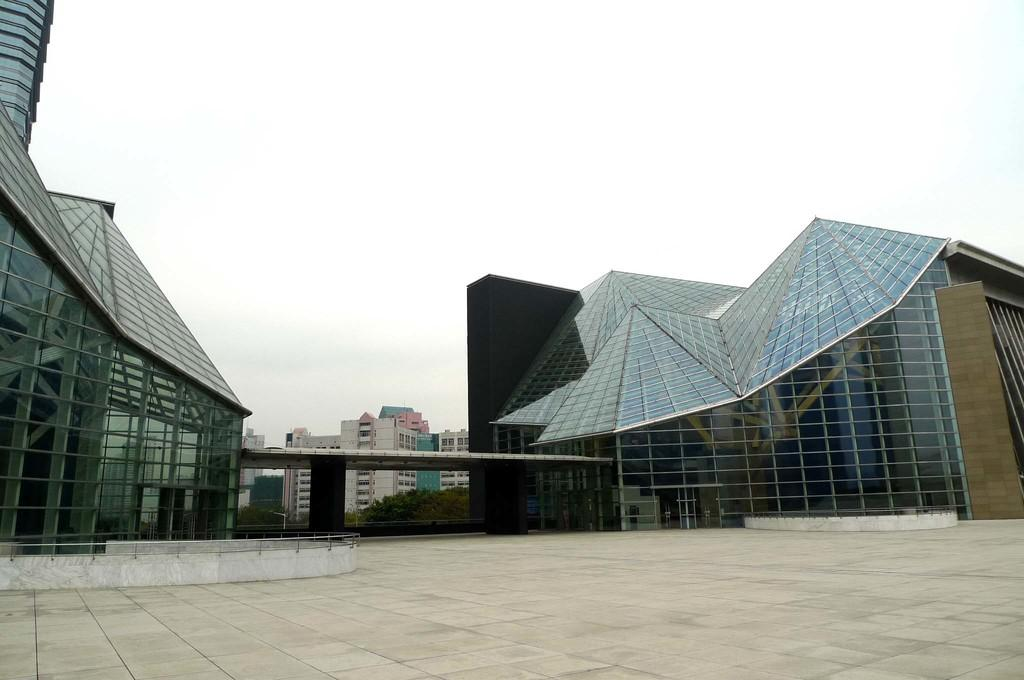What type of structures can be seen in the image? There are buildings in the image. What architectural elements are present in the image? There are walls and pillars in the image. What type of vegetation is visible in the image? There are trees in the image. What type of objects can be seen in the image? There are glass objects in the image. What is the ground surface like in the image? There is a path at the bottom of the image. What can be seen in the background of the image? The sky is visible in the background of the image. What color is the blood on the path in the image? There is no blood present in the image; it features a path, buildings, trees, and other elements, but no blood. What type of channel can be seen in the image? There is no channel present in the image. 